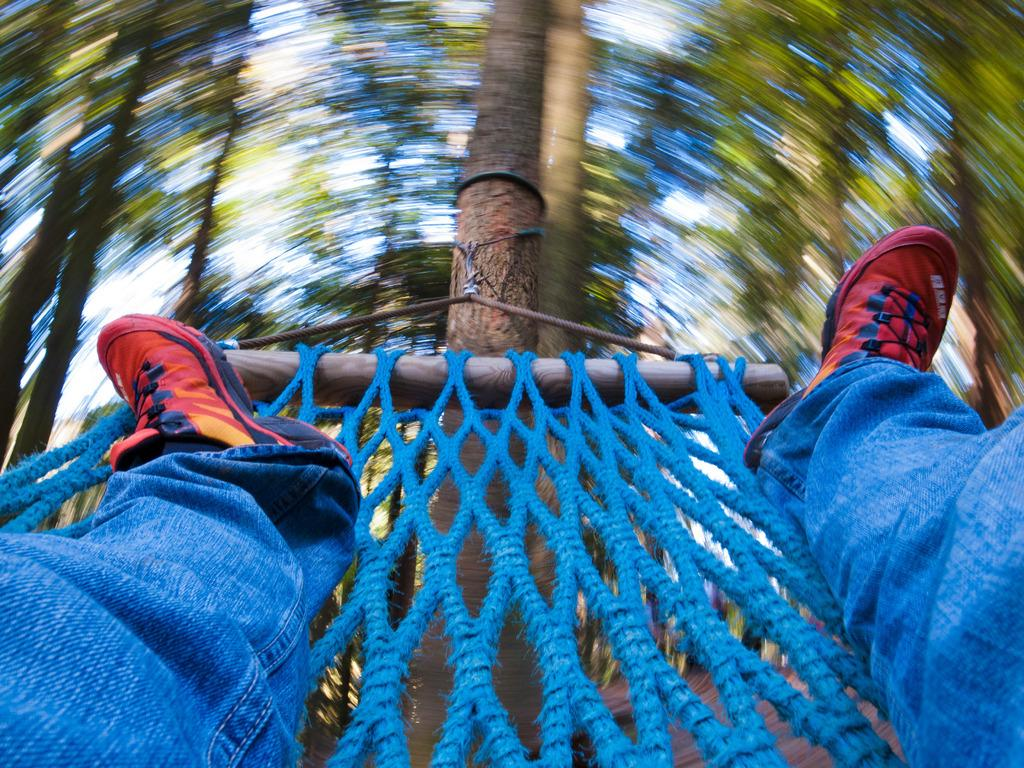What is visible in the image related to a person? There are person's legs in the image. What is the legs resting on? The legs are on a mat. How is the mat secured in the image? The mat is tied to a tree. What can be seen in the background of the image? There are trees and the sky visible in the background of the image. What type of haircut does the person have in the image? There is no visible hair in the image, as only the person's legs are shown. How does the person smash the tree in the image? There is no indication of the person smashing the tree in the image; the mat is simply tied to the tree. 